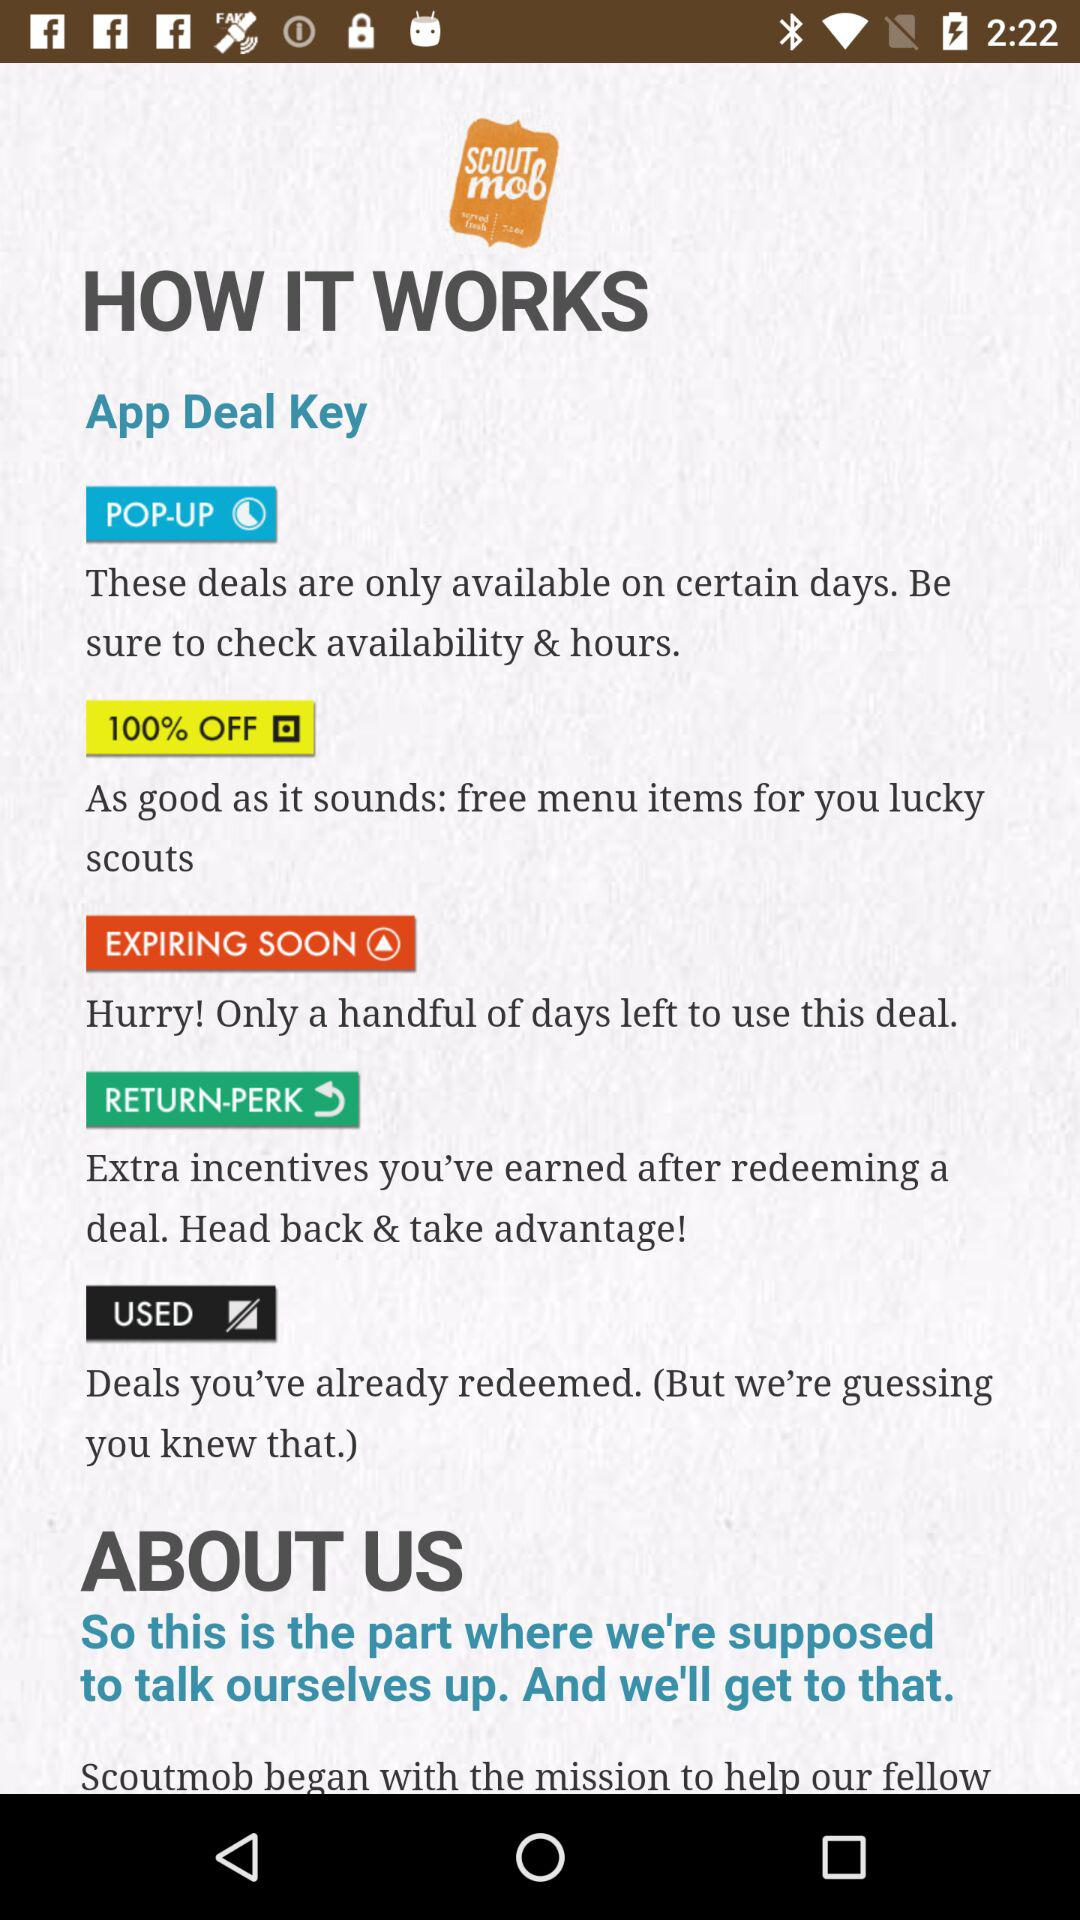What is the application name? The name of the application is "SCOUT mob". 